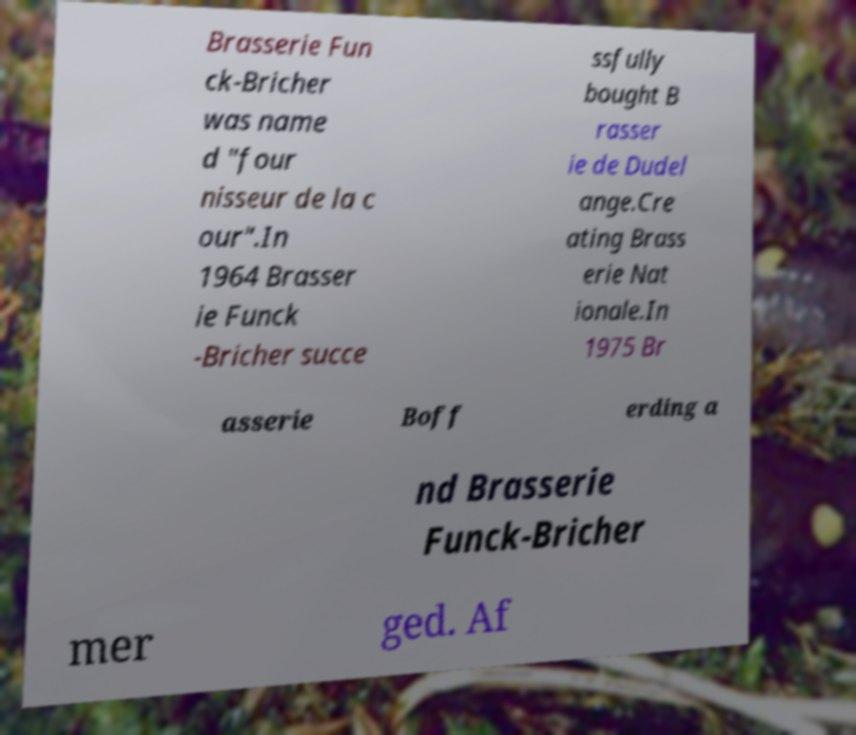There's text embedded in this image that I need extracted. Can you transcribe it verbatim? Brasserie Fun ck-Bricher was name d "four nisseur de la c our".In 1964 Brasser ie Funck -Bricher succe ssfully bought B rasser ie de Dudel ange.Cre ating Brass erie Nat ionale.In 1975 Br asserie Boff erding a nd Brasserie Funck-Bricher mer ged. Af 